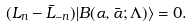<formula> <loc_0><loc_0><loc_500><loc_500>( L _ { n } - \bar { L } _ { - n } ) | B ( \alpha , \bar { \alpha } ; \Lambda ) \rangle = 0 .</formula> 